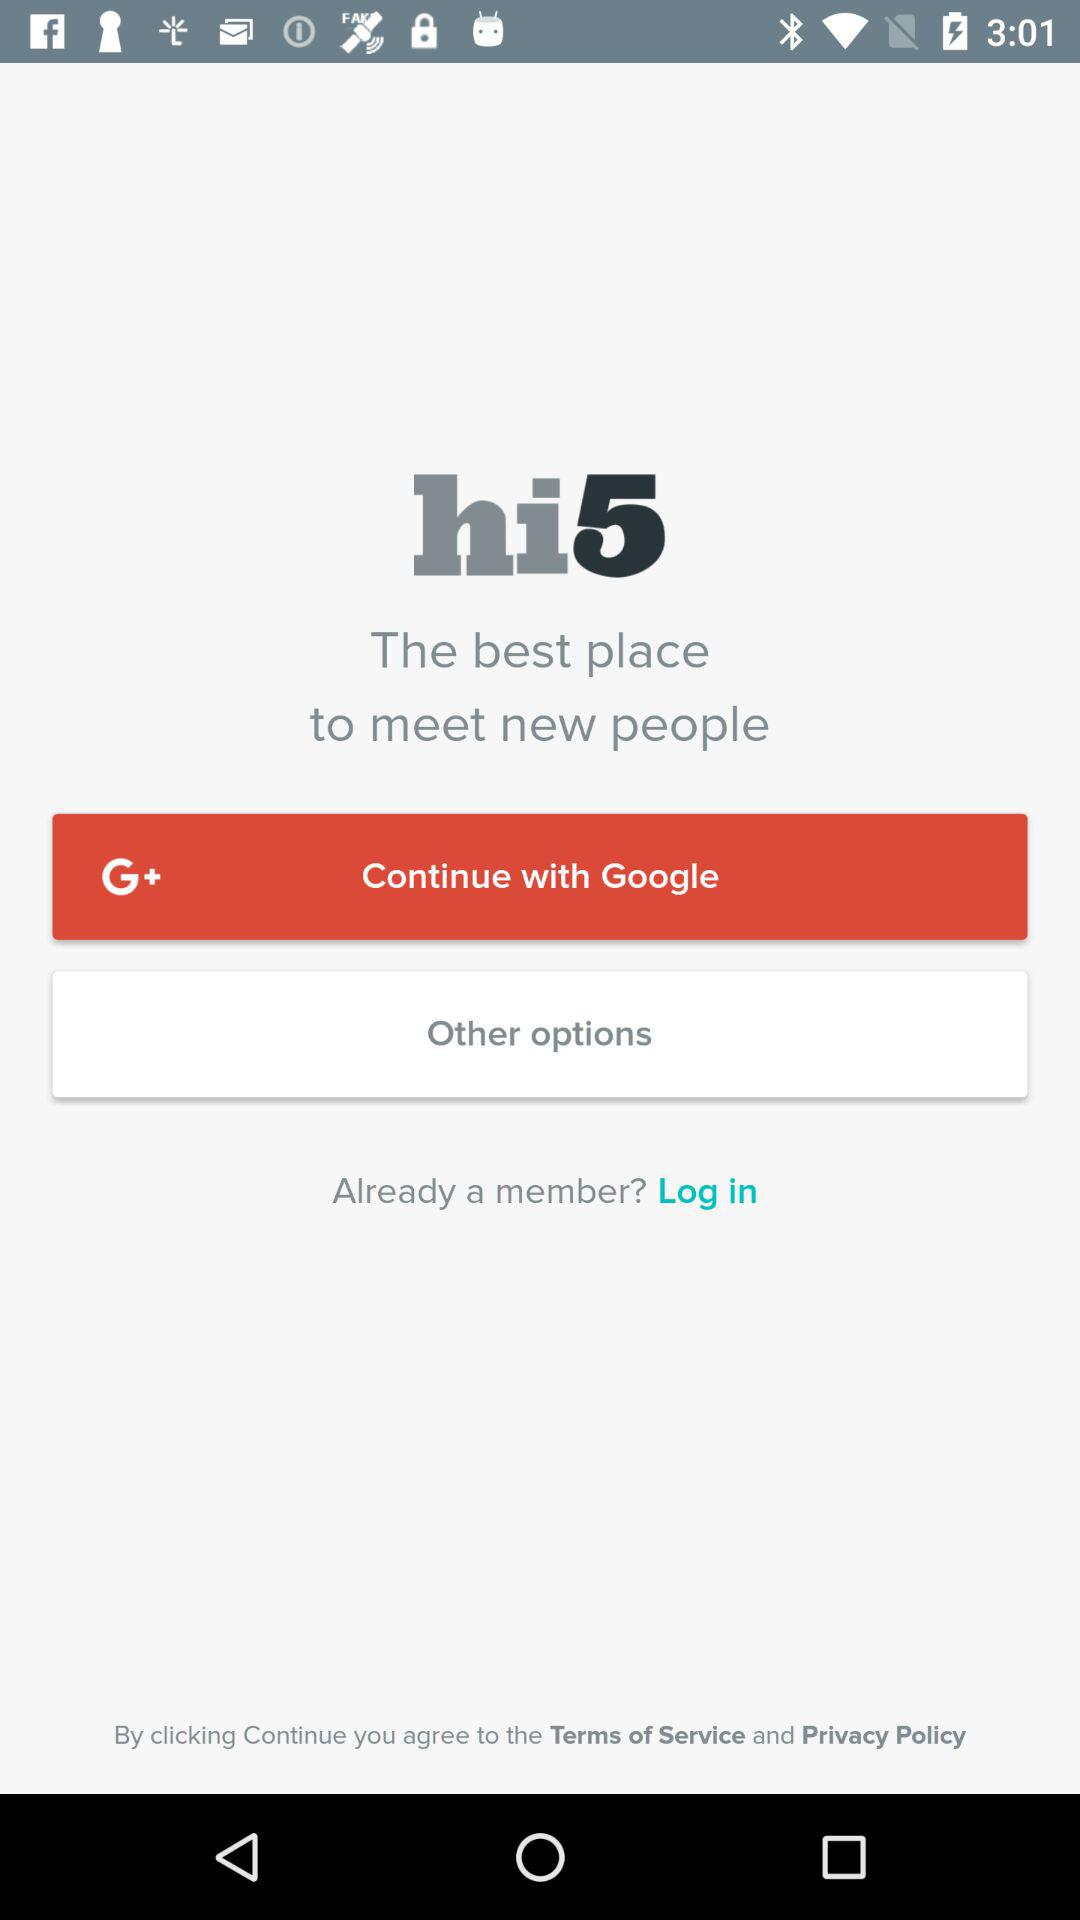What account can I use to log in? You can use your "Google" account to log in. 